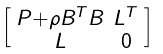Convert formula to latex. <formula><loc_0><loc_0><loc_500><loc_500>\begin{bmatrix} \begin{smallmatrix} P + \rho B ^ { T } B & L ^ { T } \\ L & 0 \end{smallmatrix} \end{bmatrix}</formula> 